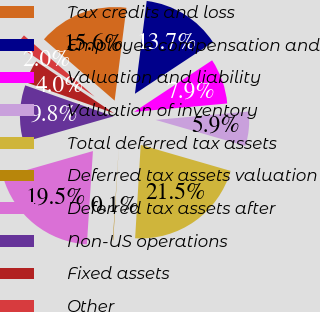Convert chart. <chart><loc_0><loc_0><loc_500><loc_500><pie_chart><fcel>Tax credits and loss<fcel>Employee compensation and<fcel>Valuation and liability<fcel>Valuation of inventory<fcel>Total deferred tax assets<fcel>Deferred tax assets valuation<fcel>Deferred tax assets after<fcel>Non-US operations<fcel>Fixed assets<fcel>Other<nl><fcel>15.64%<fcel>13.7%<fcel>7.86%<fcel>5.92%<fcel>21.47%<fcel>0.08%<fcel>19.53%<fcel>9.81%<fcel>3.97%<fcel>2.03%<nl></chart> 